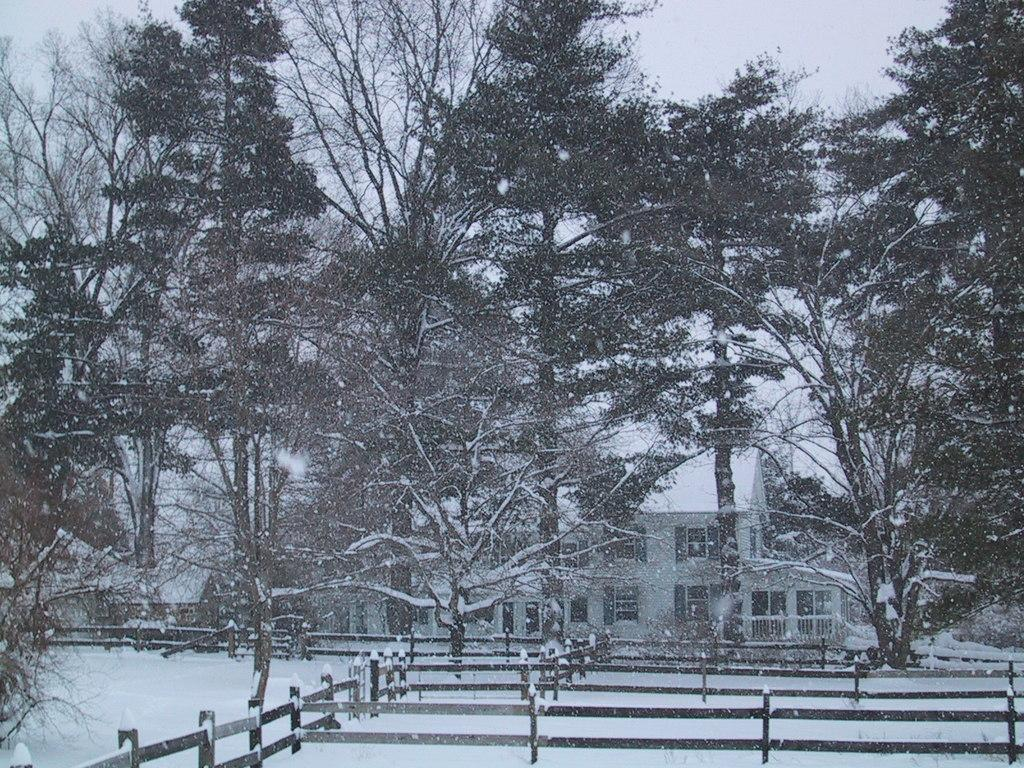What type of structure is visible in the image? There is a building with windows in the image. What kind of barrier can be seen near the building? There is a wooden fence in the image. What type of vegetation is present in the image? There is a group of trees in the image. What can be seen in the background of the image? The sky is visible in the background of the image. What type of suit is the tree wearing in the image? Trees do not wear suits, so this question cannot be answered. 